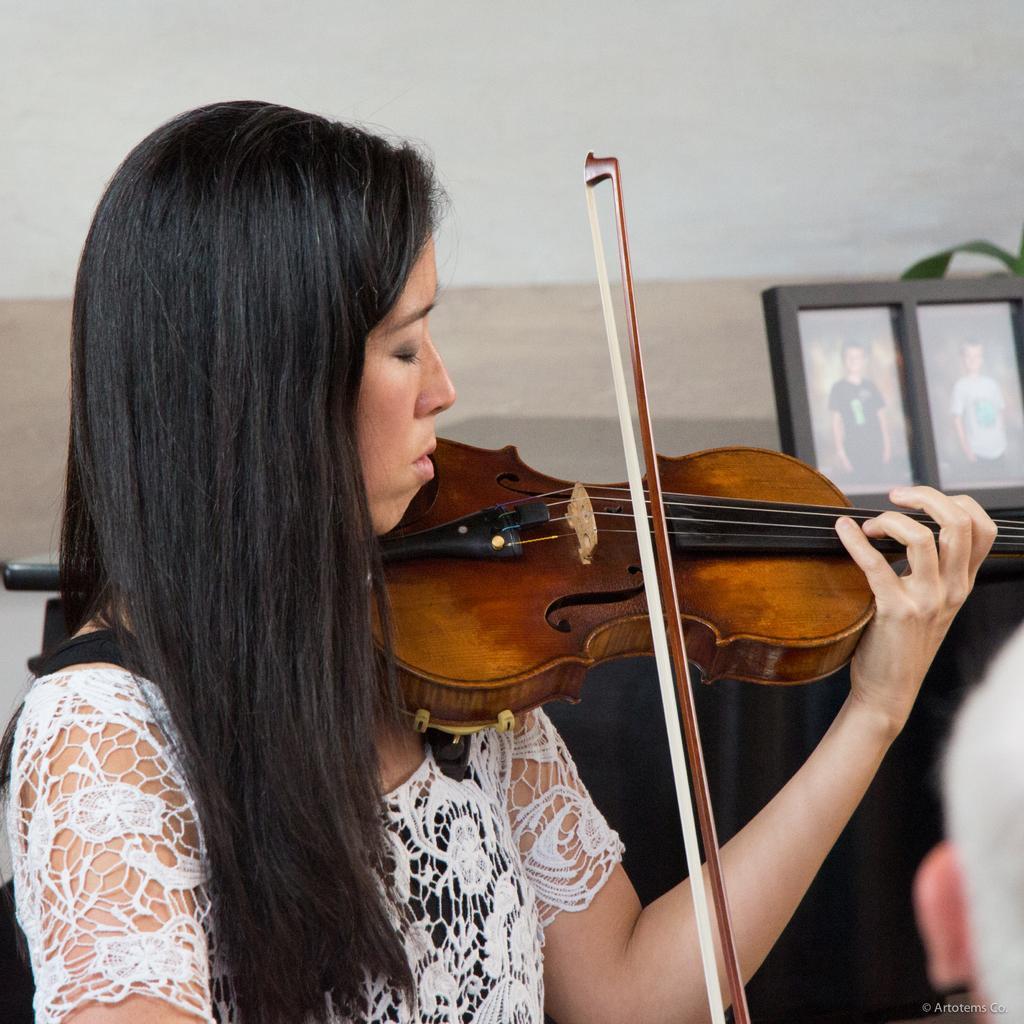In one or two sentences, can you explain what this image depicts? In this image in the middle there is a woman, she is playing a violin. In the background there are photo frames, a plant and a wall. At the bottom there is a text. 